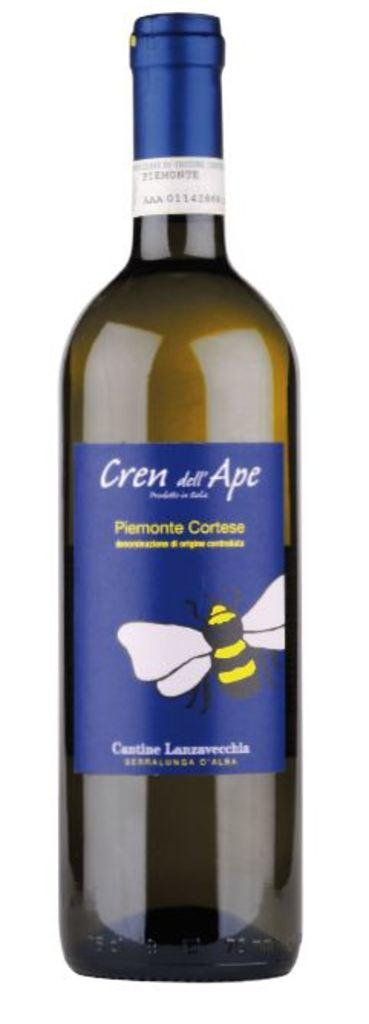<image>
Create a compact narrative representing the image presented. A bottle of Cren dell Ape wine on a white background. 